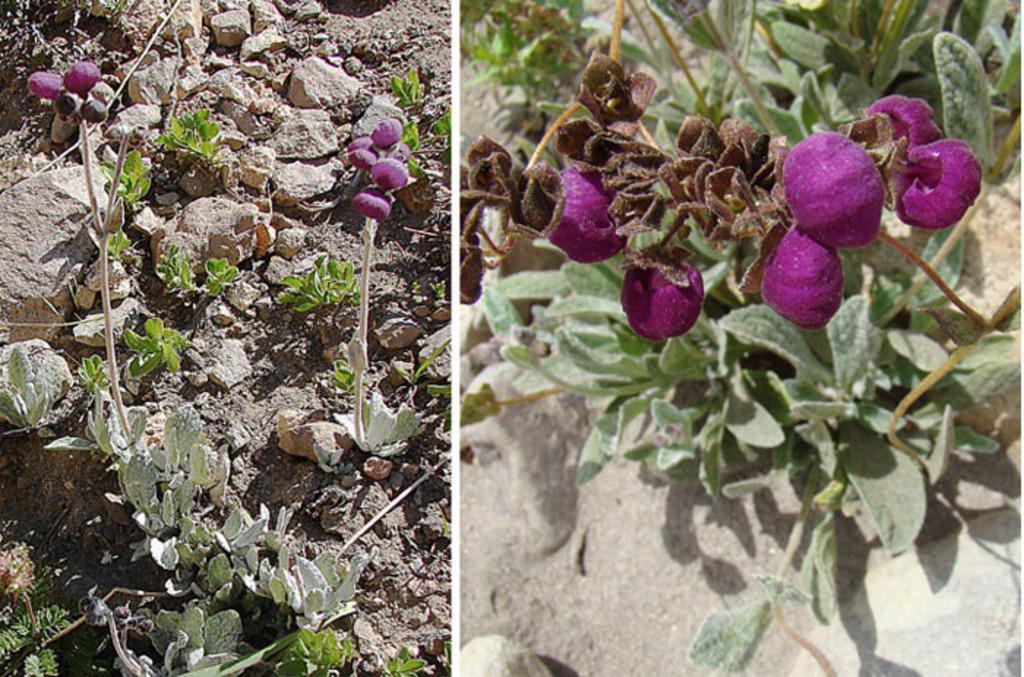Can you describe this image briefly? In this picture I can see collage of two pictures, in the first picture I can see stones and few plants on the ground, In the second picture I can see plants with flowers and few fruits or vegetables. They are purple in color. 